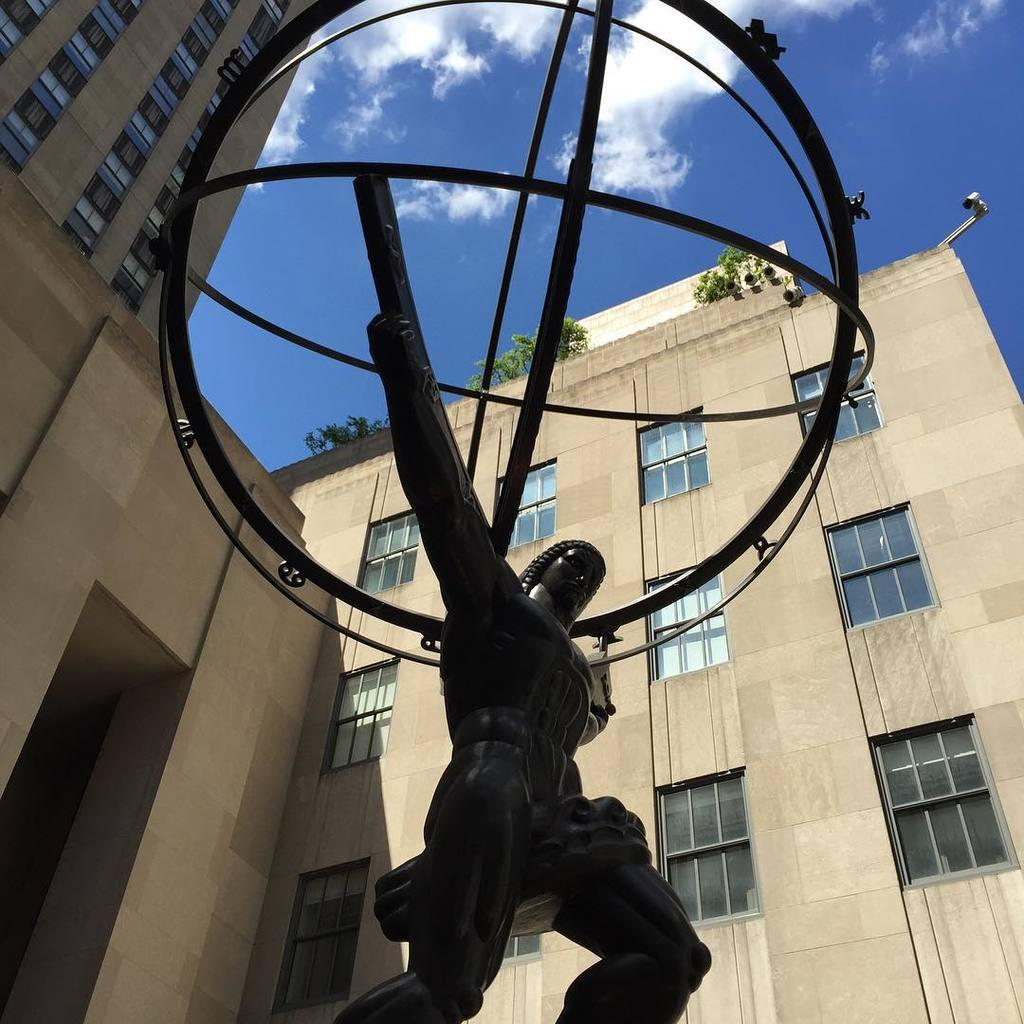What is the main subject in the image? There is a sculpture in the image. What can be seen in the distance behind the sculpture? There are buildings in the background of the image. How would you describe the sky in the image? The sky is blue with clouds. Can you see the smile on the table in the image? There is no smile or table present in the image. 